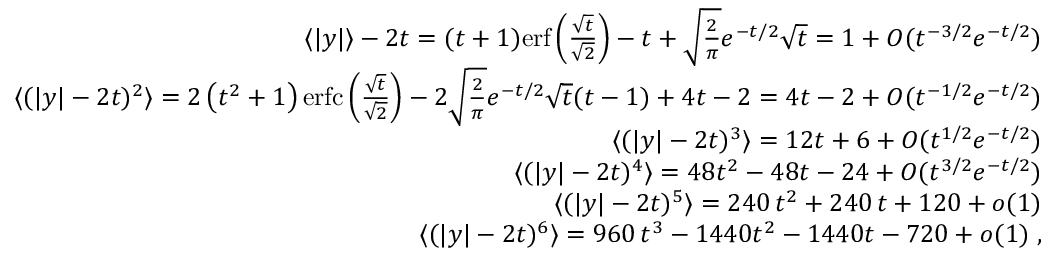<formula> <loc_0><loc_0><loc_500><loc_500>\begin{array} { r l r } & { \langle | y | \rangle - 2 t = ( t + 1 ) e r f \left ( \frac { \sqrt { t } } { \sqrt { 2 } } \right ) - t + \sqrt { \frac { 2 } { \pi } } e ^ { - t / 2 } \sqrt { t } = 1 + O ( t ^ { - 3 / 2 } e ^ { - t / 2 } ) } \\ & { \langle ( | y | - 2 t ) ^ { 2 } \rangle = 2 \left ( t ^ { 2 } + 1 \right ) e r f c \left ( \frac { \sqrt { t } } { \sqrt { 2 } } \right ) - 2 \sqrt { \frac { 2 } { \pi } } e ^ { - t / 2 } \sqrt { t } ( t - 1 ) + 4 t - 2 = 4 t - 2 + O ( t ^ { - 1 / 2 } e ^ { - t / 2 } ) } \\ & { \langle ( | y | - 2 t ) ^ { 3 } \rangle = 1 2 t + 6 + O ( t ^ { 1 / 2 } e ^ { - t / 2 } ) } \\ & { \langle ( | y | - 2 t ) ^ { 4 } \rangle = 4 8 t ^ { 2 } - 4 8 t - 2 4 + O ( t ^ { 3 / 2 } e ^ { - t / 2 } ) } \\ & { \langle ( | y | - 2 t ) ^ { 5 } \rangle = 2 4 0 \, t ^ { 2 } + 2 4 0 \, t + 1 2 0 + o ( 1 ) } \\ & { \langle ( | y | - 2 t ) ^ { 6 } \rangle = 9 6 0 \, t ^ { 3 } - 1 4 4 0 t ^ { 2 } - 1 4 4 0 t - 7 2 0 + o ( 1 ) \, , } \end{array}</formula> 